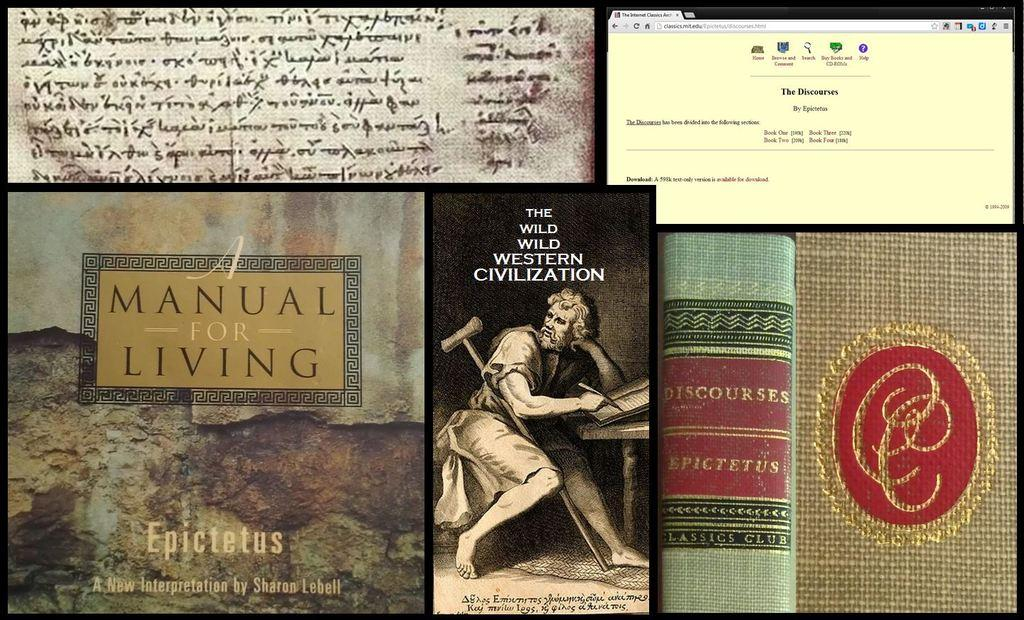<image>
Create a compact narrative representing the image presented. Collage with a picture that shows a man and the words "The Wild Wild Western Civilization". 